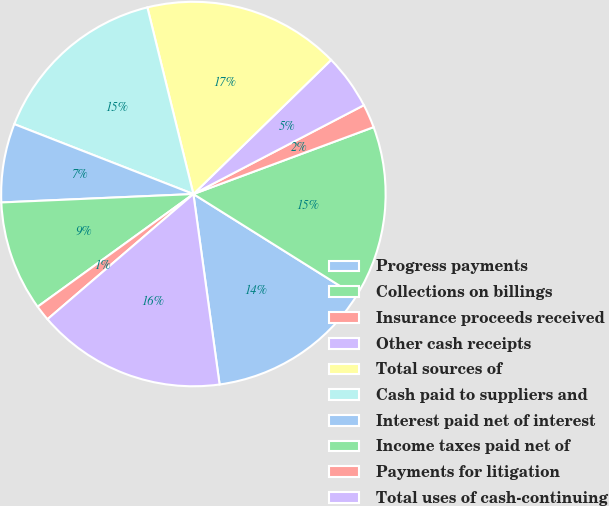Convert chart to OTSL. <chart><loc_0><loc_0><loc_500><loc_500><pie_chart><fcel>Progress payments<fcel>Collections on billings<fcel>Insurance proceeds received<fcel>Other cash receipts<fcel>Total sources of<fcel>Cash paid to suppliers and<fcel>Interest paid net of interest<fcel>Income taxes paid net of<fcel>Payments for litigation<fcel>Total uses of cash-continuing<nl><fcel>13.91%<fcel>14.57%<fcel>1.99%<fcel>4.64%<fcel>16.56%<fcel>15.23%<fcel>6.62%<fcel>9.27%<fcel>1.32%<fcel>15.89%<nl></chart> 